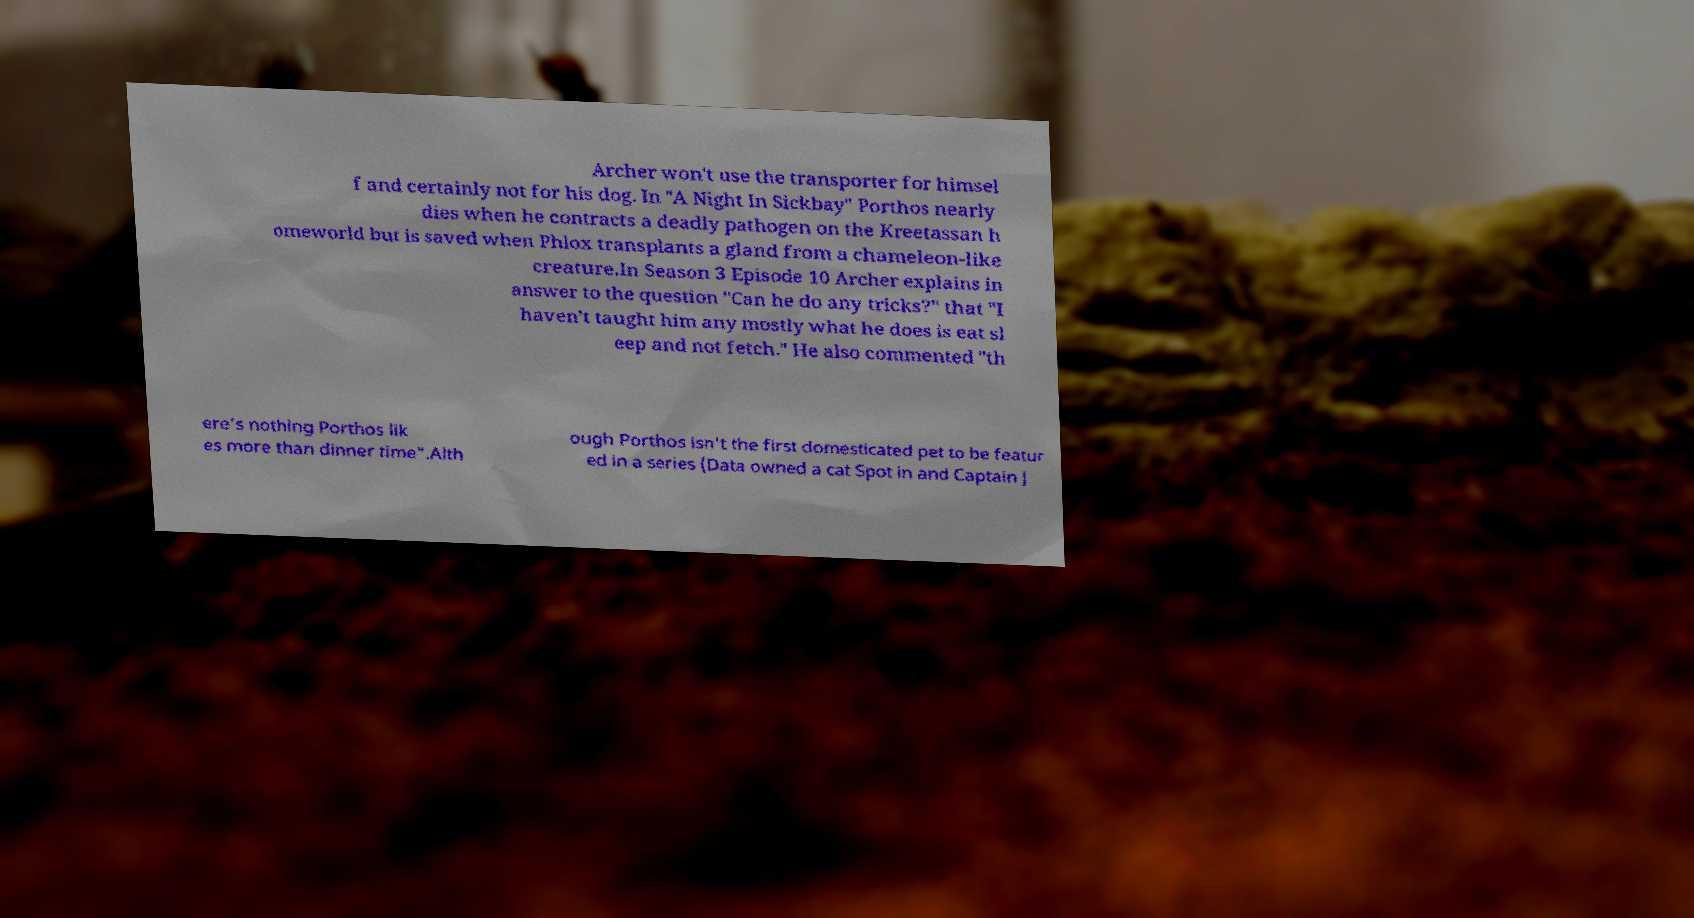Could you assist in decoding the text presented in this image and type it out clearly? Archer won't use the transporter for himsel f and certainly not for his dog. In "A Night In Sickbay" Porthos nearly dies when he contracts a deadly pathogen on the Kreetassan h omeworld but is saved when Phlox transplants a gland from a chameleon-like creature.In Season 3 Episode 10 Archer explains in answer to the question "Can he do any tricks?" that "I haven’t taught him any mostly what he does is eat sl eep and not fetch." He also commented "th ere’s nothing Porthos lik es more than dinner time".Alth ough Porthos isn't the first domesticated pet to be featur ed in a series (Data owned a cat Spot in and Captain J 